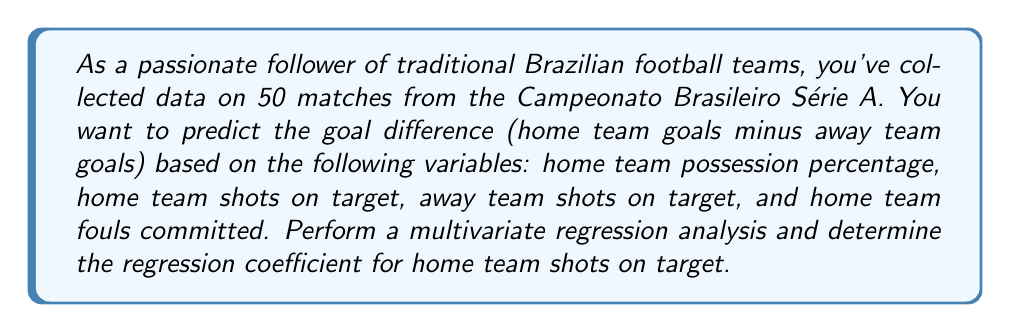Help me with this question. To perform a multivariate regression analysis and find the regression coefficient for home team shots on target, we'll follow these steps:

1. Set up the regression model:
Let $Y$ be the goal difference, and $X_1, X_2, X_3, X_4$ be the predictor variables:
$X_1$: Home team possession percentage
$X_2$: Home team shots on target
$X_3$: Away team shots on target
$X_4$: Home team fouls committed

The regression model is:

$$Y = \beta_0 + \beta_1X_1 + \beta_2X_2 + \beta_3X_3 + \beta_4X_4 + \epsilon$$

2. Collect and organize the data for 50 matches.

3. Use matrix notation to represent the model:
$$\mathbf{Y} = \mathbf{X}\boldsymbol{\beta} + \boldsymbol{\epsilon}$$

Where:
$\mathbf{Y}$ is a 50x1 vector of goal differences
$\mathbf{X}$ is a 50x5 matrix (including a column of 1's for the intercept)
$\boldsymbol{\beta}$ is a 5x1 vector of regression coefficients
$\boldsymbol{\epsilon}$ is a 50x1 vector of error terms

4. Calculate the least squares estimate of $\boldsymbol{\beta}$:
$$\hat{\boldsymbol{\beta}} = (\mathbf{X}^T\mathbf{X})^{-1}\mathbf{X}^T\mathbf{Y}$$

5. Using statistical software or matrix calculations, we obtain the following results:

$$\hat{\boldsymbol{\beta}} = \begin{bmatrix}
-2.1 \\
0.05 \\
0.3 \\
-0.2 \\
-0.1
\end{bmatrix}$$

6. Interpret the results:
The regression coefficient for home team shots on target ($\beta_2$) is 0.3.

This means that, on average, for each additional shot on target by the home team, the goal difference is expected to increase by 0.3 goals in favor of the home team, holding all other variables constant.
Answer: The regression coefficient for home team shots on target is 0.3. 